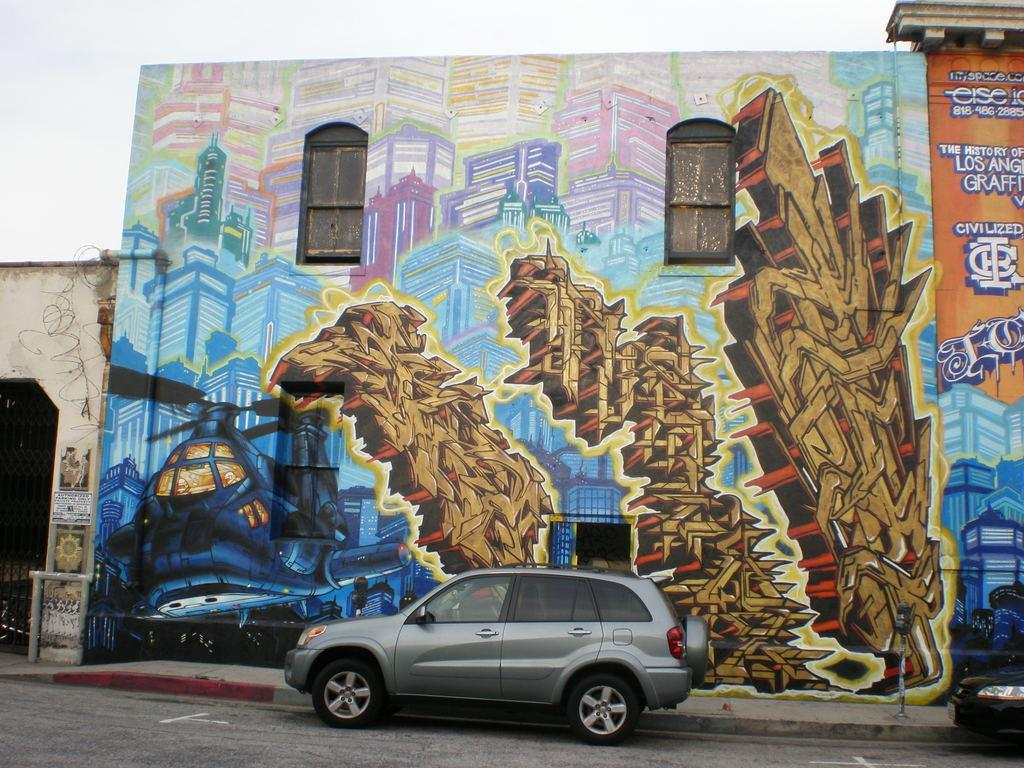What type of structures can be seen in the image? There are buildings in the image. Can you describe a specific detail about one of the buildings? There is a painting on a wall in the image. What is depicted on the painting? There is text on the painting. What type of vehicles are present in the image? There are cars in the image. How would you describe the weather in the image? The sky is cloudy in the image. How does the painting increase in size over time in the image? The painting does not increase in size over time in the image; it remains the same size. 